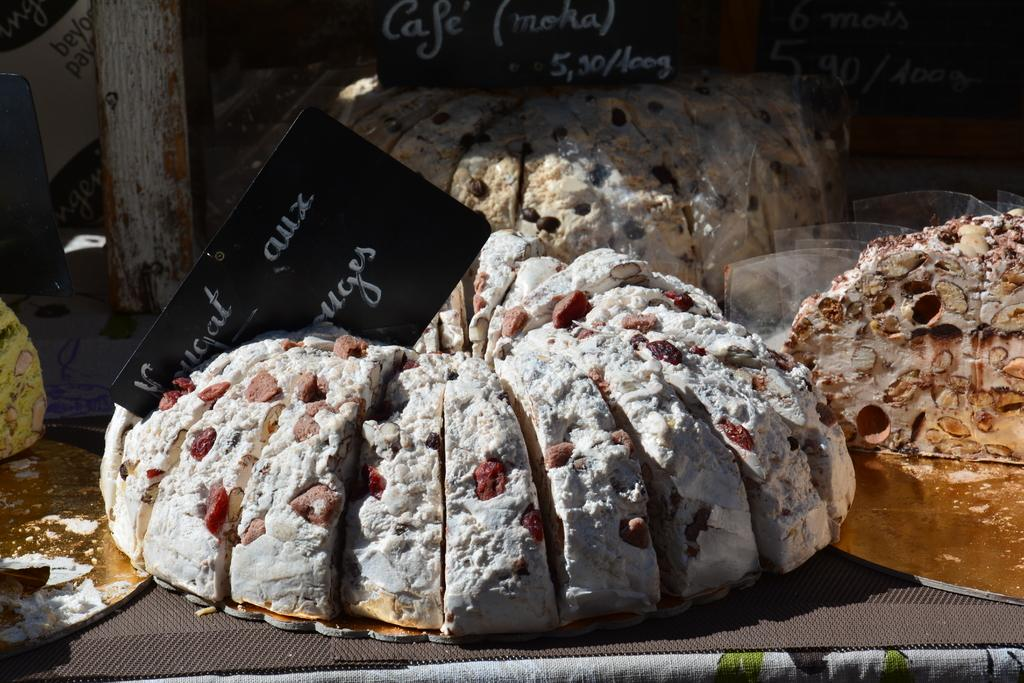What type of food items are present in the image? There are different cakes in the image. How are the cakes displayed in the image? The cakes are arranged in a rack. What can be seen on the cakes in the image? The cakes have slices. Are there any labels or text visible in the image? Yes, there are labels and text on the rack. What type of dress is the baby wearing in the image? There is no baby or dress present in the image; it features different cakes arranged in a rack. What can be seen in the aftermath of the cake-cutting event in the image? There is no cake-cutting event or aftermath depicted in the image; it simply shows cakes arranged in a rack with slices and labels. 